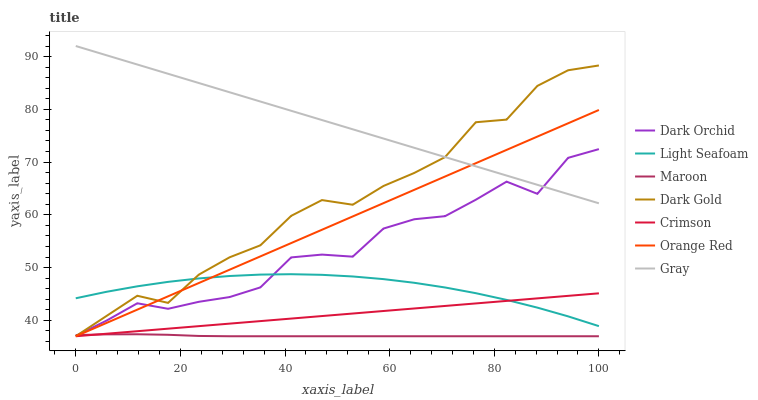Does Dark Gold have the minimum area under the curve?
Answer yes or no. No. Does Dark Gold have the maximum area under the curve?
Answer yes or no. No. Is Maroon the smoothest?
Answer yes or no. No. Is Maroon the roughest?
Answer yes or no. No. Does Dark Orchid have the lowest value?
Answer yes or no. No. Does Dark Gold have the highest value?
Answer yes or no. No. Is Crimson less than Dark Orchid?
Answer yes or no. Yes. Is Dark Orchid greater than Crimson?
Answer yes or no. Yes. Does Crimson intersect Dark Orchid?
Answer yes or no. No. 